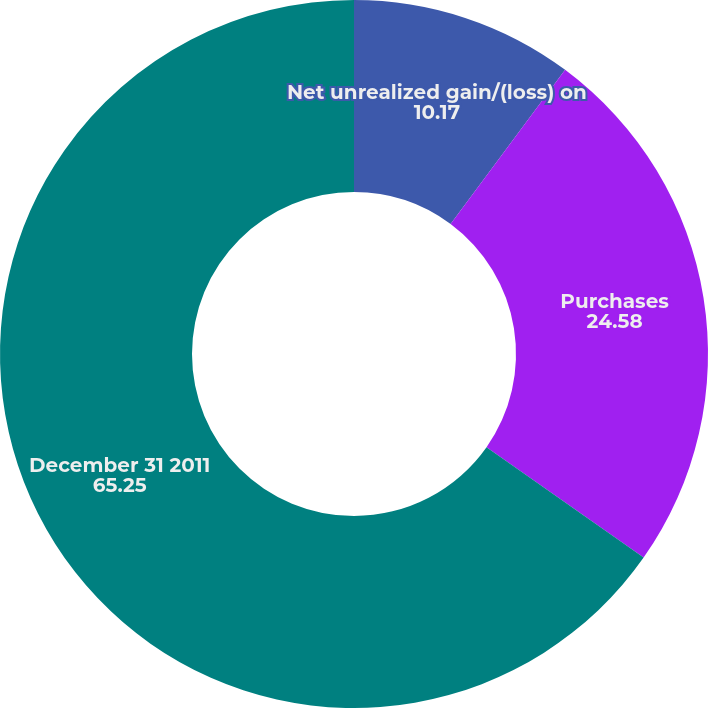Convert chart. <chart><loc_0><loc_0><loc_500><loc_500><pie_chart><fcel>Net unrealized gain/(loss) on<fcel>Purchases<fcel>December 31 2011<nl><fcel>10.17%<fcel>24.58%<fcel>65.25%<nl></chart> 